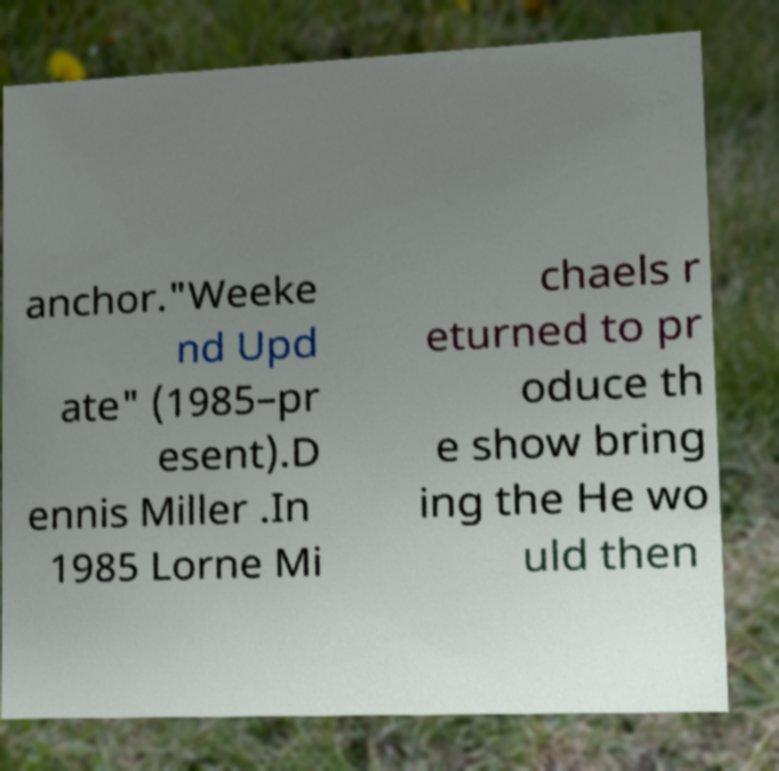Can you read and provide the text displayed in the image?This photo seems to have some interesting text. Can you extract and type it out for me? anchor."Weeke nd Upd ate" (1985–pr esent).D ennis Miller .In 1985 Lorne Mi chaels r eturned to pr oduce th e show bring ing the He wo uld then 